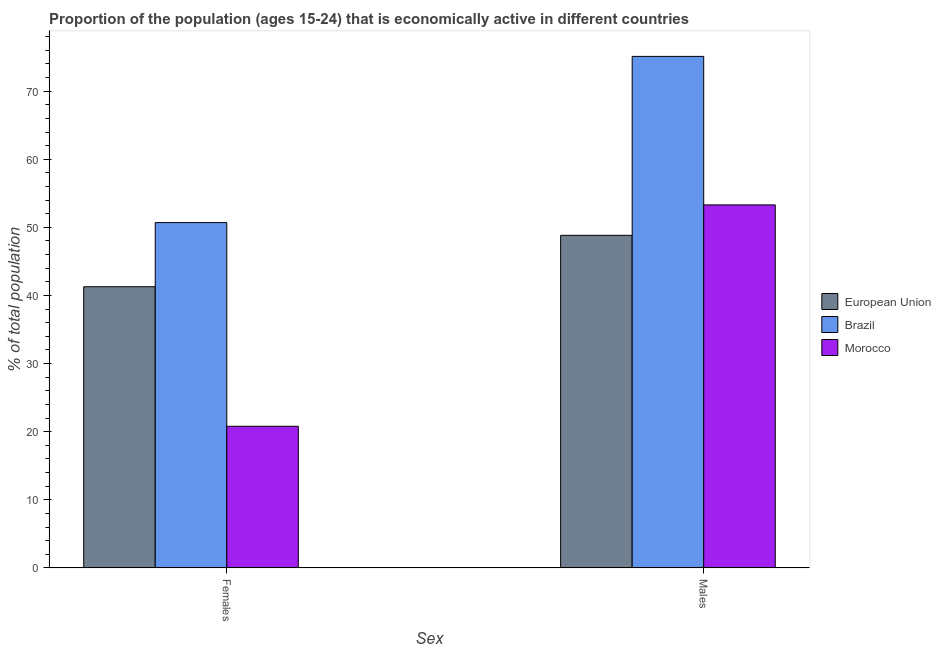Are the number of bars per tick equal to the number of legend labels?
Offer a terse response. Yes. Are the number of bars on each tick of the X-axis equal?
Give a very brief answer. Yes. How many bars are there on the 1st tick from the left?
Ensure brevity in your answer.  3. What is the label of the 2nd group of bars from the left?
Offer a terse response. Males. What is the percentage of economically active female population in European Union?
Ensure brevity in your answer.  41.28. Across all countries, what is the maximum percentage of economically active male population?
Your answer should be compact. 75.1. Across all countries, what is the minimum percentage of economically active female population?
Offer a terse response. 20.8. In which country was the percentage of economically active female population maximum?
Ensure brevity in your answer.  Brazil. What is the total percentage of economically active female population in the graph?
Ensure brevity in your answer.  112.78. What is the difference between the percentage of economically active female population in Morocco and that in Brazil?
Provide a succinct answer. -29.9. What is the difference between the percentage of economically active male population in Brazil and the percentage of economically active female population in Morocco?
Ensure brevity in your answer.  54.3. What is the average percentage of economically active male population per country?
Give a very brief answer. 59.08. What is the difference between the percentage of economically active female population and percentage of economically active male population in Brazil?
Your answer should be compact. -24.4. What is the ratio of the percentage of economically active female population in Brazil to that in Morocco?
Provide a short and direct response. 2.44. Is the percentage of economically active male population in European Union less than that in Brazil?
Make the answer very short. Yes. In how many countries, is the percentage of economically active male population greater than the average percentage of economically active male population taken over all countries?
Make the answer very short. 1. What does the 1st bar from the right in Females represents?
Ensure brevity in your answer.  Morocco. How many countries are there in the graph?
Keep it short and to the point. 3. What is the difference between two consecutive major ticks on the Y-axis?
Provide a short and direct response. 10. Does the graph contain any zero values?
Offer a very short reply. No. Where does the legend appear in the graph?
Provide a short and direct response. Center right. What is the title of the graph?
Provide a succinct answer. Proportion of the population (ages 15-24) that is economically active in different countries. What is the label or title of the X-axis?
Provide a short and direct response. Sex. What is the label or title of the Y-axis?
Your answer should be compact. % of total population. What is the % of total population in European Union in Females?
Offer a very short reply. 41.28. What is the % of total population in Brazil in Females?
Your answer should be very brief. 50.7. What is the % of total population of Morocco in Females?
Provide a short and direct response. 20.8. What is the % of total population in European Union in Males?
Offer a terse response. 48.83. What is the % of total population in Brazil in Males?
Your answer should be compact. 75.1. What is the % of total population in Morocco in Males?
Make the answer very short. 53.3. Across all Sex, what is the maximum % of total population in European Union?
Keep it short and to the point. 48.83. Across all Sex, what is the maximum % of total population of Brazil?
Make the answer very short. 75.1. Across all Sex, what is the maximum % of total population in Morocco?
Provide a succinct answer. 53.3. Across all Sex, what is the minimum % of total population of European Union?
Keep it short and to the point. 41.28. Across all Sex, what is the minimum % of total population in Brazil?
Give a very brief answer. 50.7. Across all Sex, what is the minimum % of total population in Morocco?
Your response must be concise. 20.8. What is the total % of total population in European Union in the graph?
Give a very brief answer. 90.11. What is the total % of total population in Brazil in the graph?
Give a very brief answer. 125.8. What is the total % of total population in Morocco in the graph?
Give a very brief answer. 74.1. What is the difference between the % of total population in European Union in Females and that in Males?
Make the answer very short. -7.55. What is the difference between the % of total population in Brazil in Females and that in Males?
Provide a short and direct response. -24.4. What is the difference between the % of total population in Morocco in Females and that in Males?
Give a very brief answer. -32.5. What is the difference between the % of total population of European Union in Females and the % of total population of Brazil in Males?
Your answer should be very brief. -33.82. What is the difference between the % of total population of European Union in Females and the % of total population of Morocco in Males?
Offer a very short reply. -12.02. What is the average % of total population in European Union per Sex?
Your response must be concise. 45.06. What is the average % of total population in Brazil per Sex?
Provide a short and direct response. 62.9. What is the average % of total population of Morocco per Sex?
Ensure brevity in your answer.  37.05. What is the difference between the % of total population of European Union and % of total population of Brazil in Females?
Provide a short and direct response. -9.42. What is the difference between the % of total population of European Union and % of total population of Morocco in Females?
Keep it short and to the point. 20.48. What is the difference between the % of total population of Brazil and % of total population of Morocco in Females?
Offer a very short reply. 29.9. What is the difference between the % of total population of European Union and % of total population of Brazil in Males?
Give a very brief answer. -26.27. What is the difference between the % of total population of European Union and % of total population of Morocco in Males?
Your answer should be very brief. -4.47. What is the difference between the % of total population of Brazil and % of total population of Morocco in Males?
Offer a very short reply. 21.8. What is the ratio of the % of total population in European Union in Females to that in Males?
Provide a short and direct response. 0.85. What is the ratio of the % of total population in Brazil in Females to that in Males?
Make the answer very short. 0.68. What is the ratio of the % of total population in Morocco in Females to that in Males?
Offer a terse response. 0.39. What is the difference between the highest and the second highest % of total population in European Union?
Keep it short and to the point. 7.55. What is the difference between the highest and the second highest % of total population in Brazil?
Keep it short and to the point. 24.4. What is the difference between the highest and the second highest % of total population of Morocco?
Keep it short and to the point. 32.5. What is the difference between the highest and the lowest % of total population in European Union?
Offer a terse response. 7.55. What is the difference between the highest and the lowest % of total population of Brazil?
Offer a very short reply. 24.4. What is the difference between the highest and the lowest % of total population of Morocco?
Offer a terse response. 32.5. 